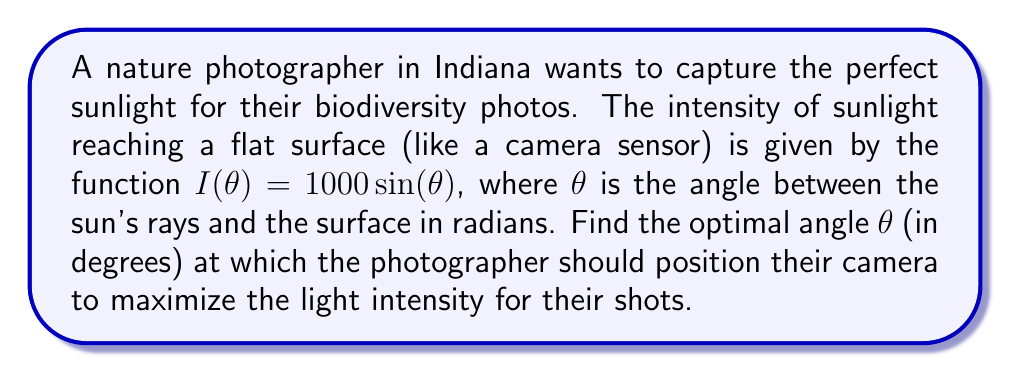Help me with this question. To find the optimal angle, we need to maximize the function $I(\theta) = 1000 \sin(\theta)$. We can do this by finding the derivative and setting it equal to zero.

1) First, let's find the derivative of $I(\theta)$:
   $$\frac{dI}{d\theta} = 1000 \cos(\theta)$$

2) Now, set this equal to zero and solve for $\theta$:
   $$1000 \cos(\theta) = 0$$
   $$\cos(\theta) = 0$$

3) The cosine function equals zero when its argument is $\frac{\pi}{2}$ radians (or 90 degrees).

4) To confirm this is a maximum (not a minimum), we can check the second derivative:
   $$\frac{d^2I}{d\theta^2} = -1000 \sin(\theta)$$
   At $\theta = \frac{\pi}{2}$, this is negative, confirming a maximum.

5) Convert $\frac{\pi}{2}$ radians to degrees:
   $$\frac{\pi}{2} \cdot \frac{180°}{\pi} = 90°$$

Therefore, the optimal angle for the photographer to position their camera is 90 degrees relative to the sun's rays, or perpendicular to them.
Answer: 90° 